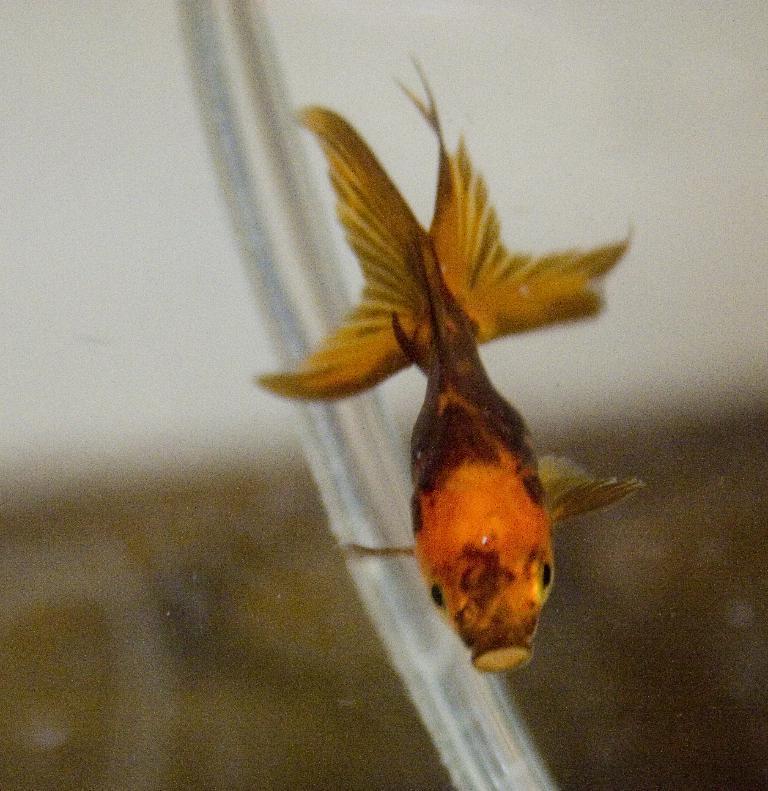In one or two sentences, can you explain what this image depicts? In this image we can see a fish under water and the background image is blurred. 